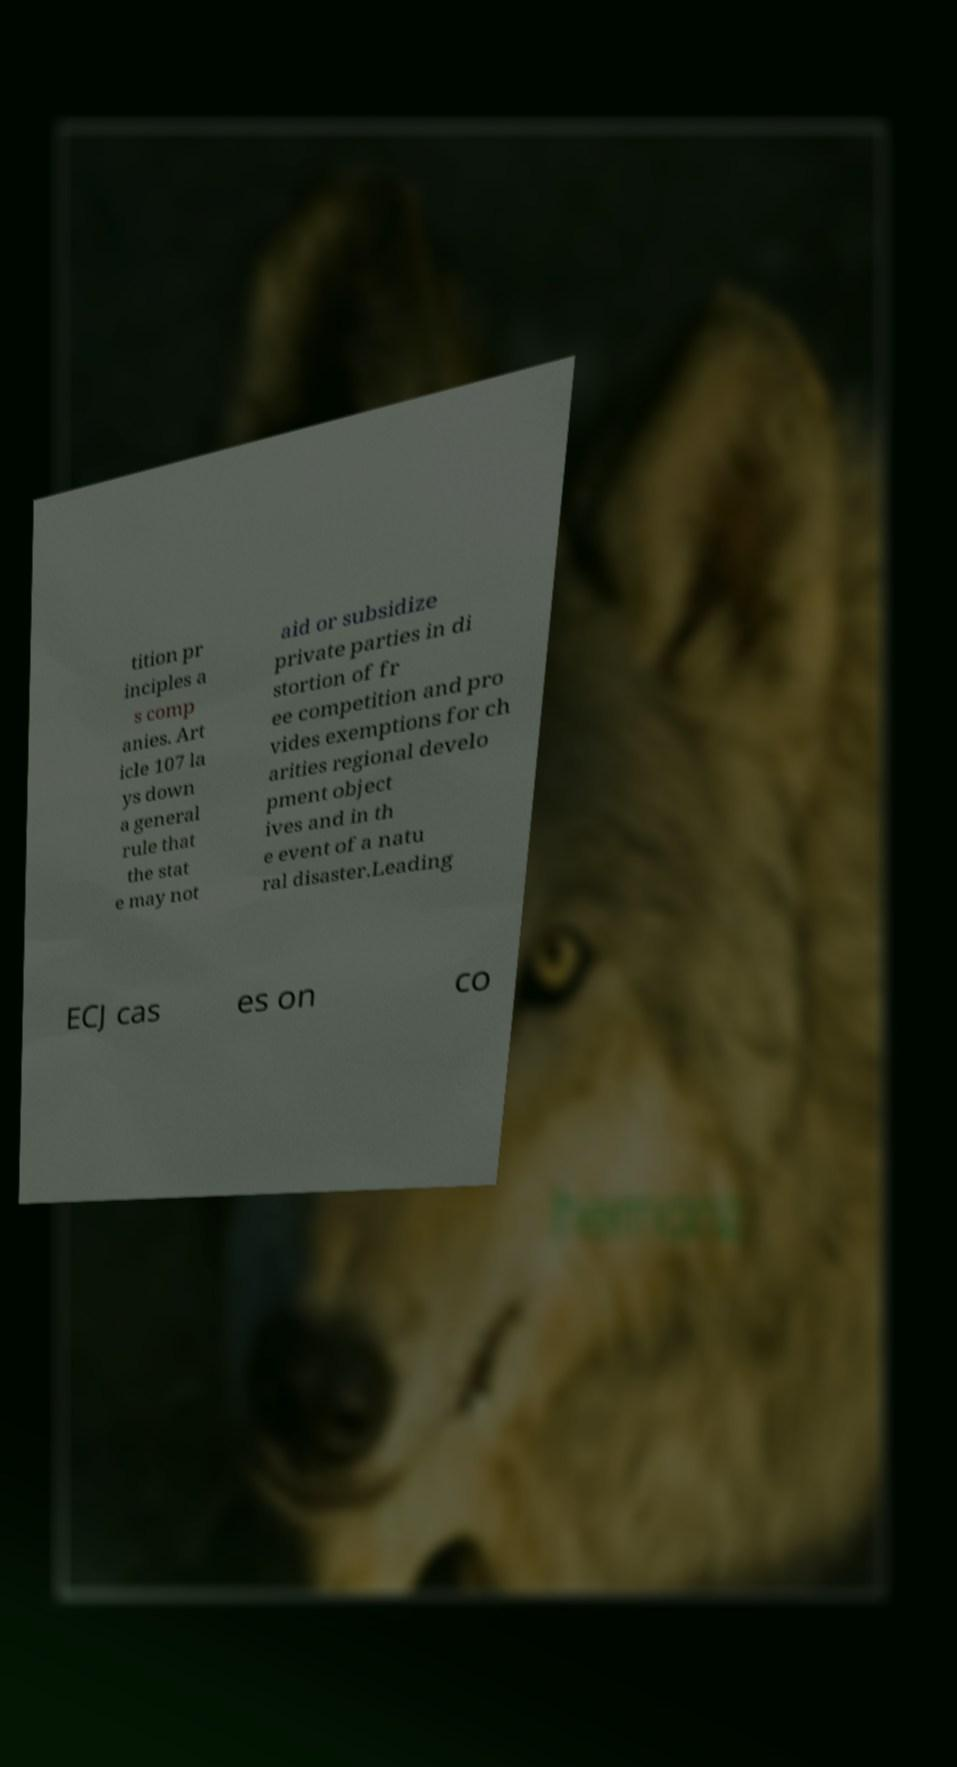Please read and relay the text visible in this image. What does it say? tition pr inciples a s comp anies. Art icle 107 la ys down a general rule that the stat e may not aid or subsidize private parties in di stortion of fr ee competition and pro vides exemptions for ch arities regional develo pment object ives and in th e event of a natu ral disaster.Leading ECJ cas es on co 